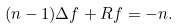Convert formula to latex. <formula><loc_0><loc_0><loc_500><loc_500>( n - 1 ) \Delta f + R f = - n .</formula> 